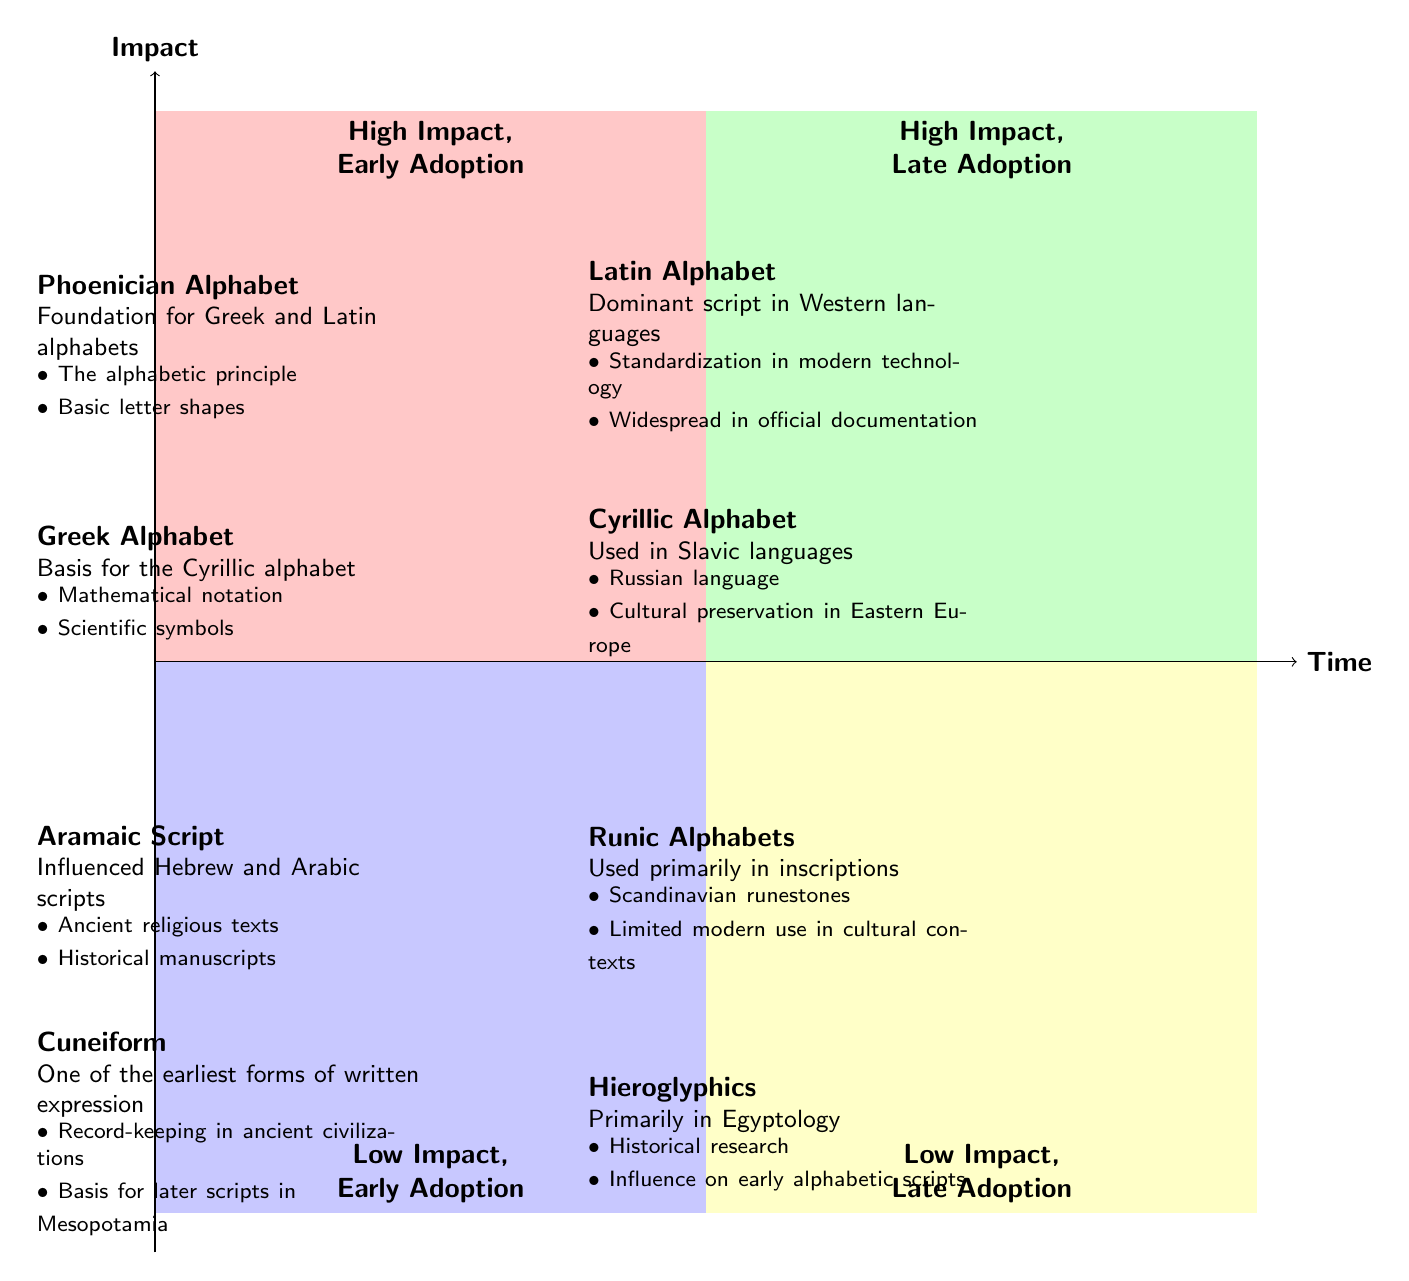What writing system is in the High Impact, Early Adoption quadrant? The High Impact, Early Adoption quadrant includes the Phoenician Alphabet and the Greek Alphabet. By looking at that specific quadrant of the diagram, we can identify both writing systems listed there.
Answer: Phoenician Alphabet How many writing systems are in the Low Impact, Late Adoption quadrant? The Low Impact, Late Adoption quadrant contains two writing systems: Runic Alphabets and Hieroglyphics. Counting the elements in that quadrant shows us there are two.
Answer: 2 Which writing system influenced the Hebrew and Arabic scripts? The Aramaic Script is located in the Low Impact, Early Adoption quadrant and is noted for influencing Hebrew and Arabic scripts. Checking the description in that quadrant confirms this influence.
Answer: Aramaic Script What is the modern usage description for the Latin Alphabet? The Latin Alphabet's modern usage description states that it is the dominant script in Western languages. This information can be found in the High Impact, Late Adoption quadrant.
Answer: Dominant script in Western languages Which quadrant contains the Cuneiform writing system? The Cuneiform writing system is found in the Low Impact, Early Adoption quadrant. By identifying where Cuneiform is located in the diagram, we can confirm this quadrant.
Answer: Low Impact, Early Adoption What examples are associated with the Greek Alphabet? The Greek Alphabet has examples of mathematical notation and scientific symbols, which are listed under its description in the High Impact, Early Adoption quadrant. Verifying the examples section verifies this information.
Answer: Mathematical notation, Scientific symbols Which writing system's modern usage includes cultural preservation in Eastern Europe? The Cyrillic Alphabet has a description stating its modern usage involves cultural preservation in Eastern Europe. It is located in the High Impact, Late Adoption quadrant.
Answer: Cyrillic Alphabet What is the main influence of the Phoenician Alphabet? The Phoenician Alphabet is described as the foundation for Greek and Latin alphabets, which outlines its influence on those writing systems. This influence is found in the High Impact, Early Adoption quadrant.
Answer: Foundation for Greek and Latin alphabets 